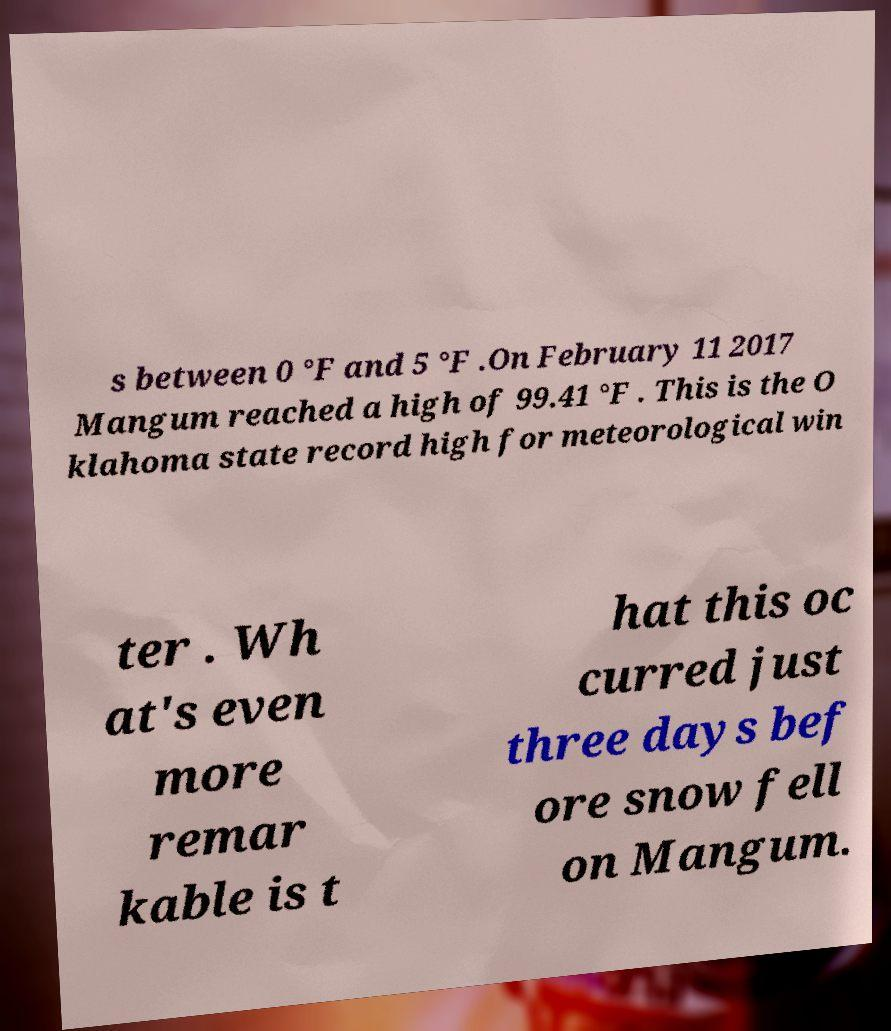Could you assist in decoding the text presented in this image and type it out clearly? s between 0 °F and 5 °F .On February 11 2017 Mangum reached a high of 99.41 °F . This is the O klahoma state record high for meteorological win ter . Wh at's even more remar kable is t hat this oc curred just three days bef ore snow fell on Mangum. 